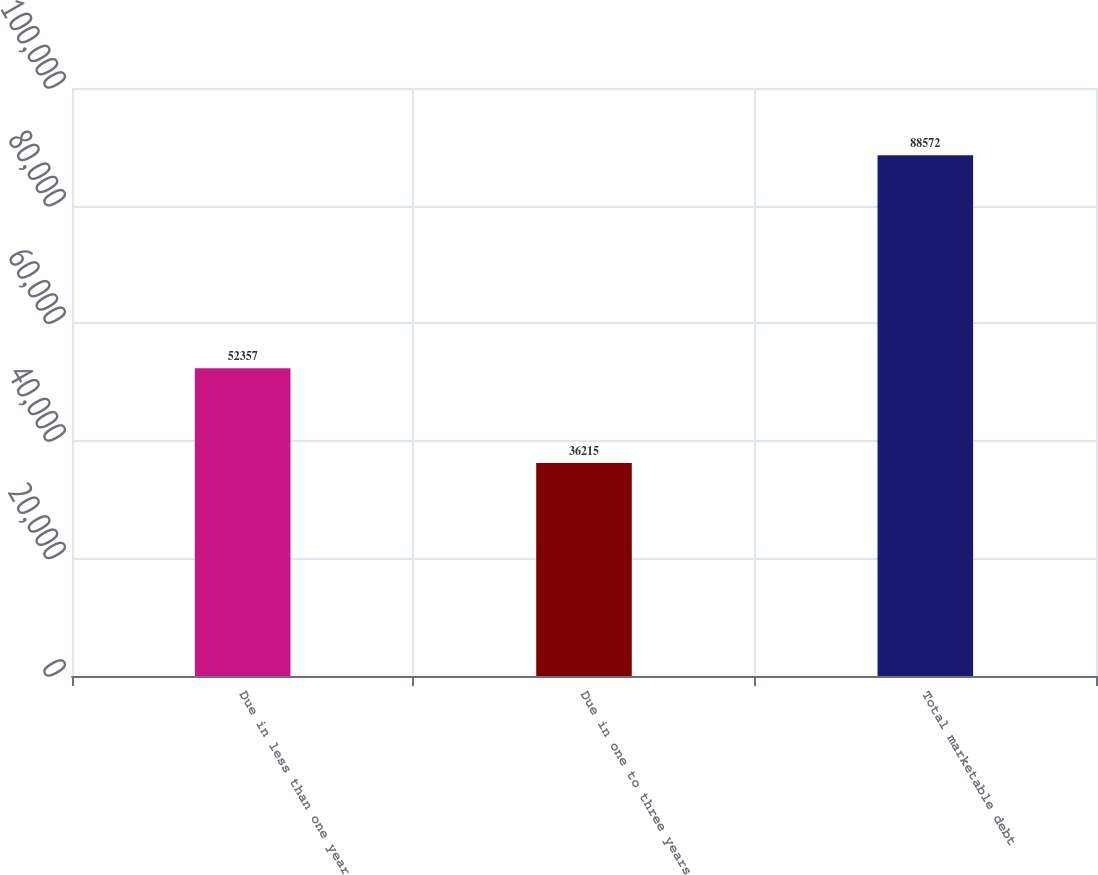<chart> <loc_0><loc_0><loc_500><loc_500><bar_chart><fcel>Due in less than one year<fcel>Due in one to three years<fcel>Total marketable debt<nl><fcel>52357<fcel>36215<fcel>88572<nl></chart> 